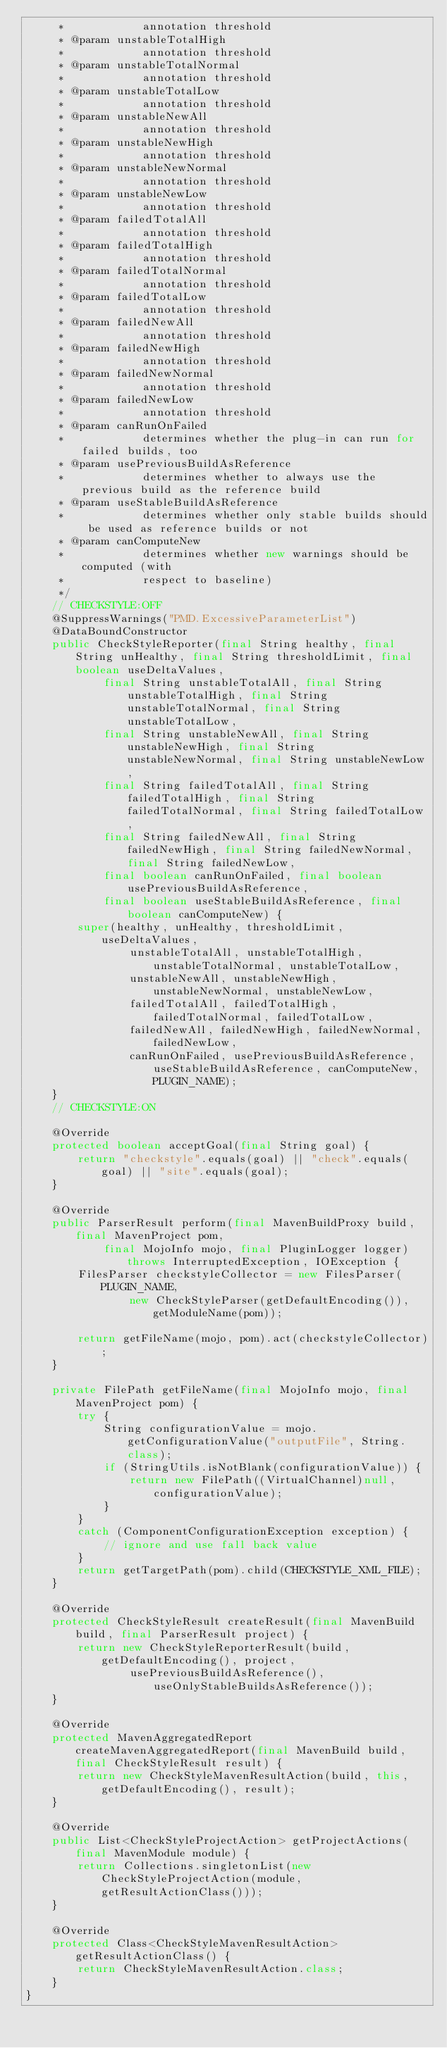Convert code to text. <code><loc_0><loc_0><loc_500><loc_500><_Java_>     *            annotation threshold
     * @param unstableTotalHigh
     *            annotation threshold
     * @param unstableTotalNormal
     *            annotation threshold
     * @param unstableTotalLow
     *            annotation threshold
     * @param unstableNewAll
     *            annotation threshold
     * @param unstableNewHigh
     *            annotation threshold
     * @param unstableNewNormal
     *            annotation threshold
     * @param unstableNewLow
     *            annotation threshold
     * @param failedTotalAll
     *            annotation threshold
     * @param failedTotalHigh
     *            annotation threshold
     * @param failedTotalNormal
     *            annotation threshold
     * @param failedTotalLow
     *            annotation threshold
     * @param failedNewAll
     *            annotation threshold
     * @param failedNewHigh
     *            annotation threshold
     * @param failedNewNormal
     *            annotation threshold
     * @param failedNewLow
     *            annotation threshold
     * @param canRunOnFailed
     *            determines whether the plug-in can run for failed builds, too
     * @param usePreviousBuildAsReference
     *            determines whether to always use the previous build as the reference build
     * @param useStableBuildAsReference
     *            determines whether only stable builds should be used as reference builds or not
     * @param canComputeNew
     *            determines whether new warnings should be computed (with
     *            respect to baseline)
     */
    // CHECKSTYLE:OFF
    @SuppressWarnings("PMD.ExcessiveParameterList")
    @DataBoundConstructor
    public CheckStyleReporter(final String healthy, final String unHealthy, final String thresholdLimit, final boolean useDeltaValues,
            final String unstableTotalAll, final String unstableTotalHigh, final String unstableTotalNormal, final String unstableTotalLow,
            final String unstableNewAll, final String unstableNewHigh, final String unstableNewNormal, final String unstableNewLow,
            final String failedTotalAll, final String failedTotalHigh, final String failedTotalNormal, final String failedTotalLow,
            final String failedNewAll, final String failedNewHigh, final String failedNewNormal, final String failedNewLow,
            final boolean canRunOnFailed, final boolean usePreviousBuildAsReference,
            final boolean useStableBuildAsReference, final boolean canComputeNew) {
        super(healthy, unHealthy, thresholdLimit, useDeltaValues,
                unstableTotalAll, unstableTotalHigh, unstableTotalNormal, unstableTotalLow,
                unstableNewAll, unstableNewHigh, unstableNewNormal, unstableNewLow,
                failedTotalAll, failedTotalHigh, failedTotalNormal, failedTotalLow,
                failedNewAll, failedNewHigh, failedNewNormal, failedNewLow,
                canRunOnFailed, usePreviousBuildAsReference, useStableBuildAsReference, canComputeNew, PLUGIN_NAME);
    }
    // CHECKSTYLE:ON

    @Override
    protected boolean acceptGoal(final String goal) {
        return "checkstyle".equals(goal) || "check".equals(goal) || "site".equals(goal);
    }

    @Override
    public ParserResult perform(final MavenBuildProxy build, final MavenProject pom,
            final MojoInfo mojo, final PluginLogger logger) throws InterruptedException, IOException {
        FilesParser checkstyleCollector = new FilesParser(PLUGIN_NAME,
                new CheckStyleParser(getDefaultEncoding()), getModuleName(pom));

        return getFileName(mojo, pom).act(checkstyleCollector);
    }

    private FilePath getFileName(final MojoInfo mojo, final MavenProject pom) {
        try {
            String configurationValue = mojo.getConfigurationValue("outputFile", String.class);
            if (StringUtils.isNotBlank(configurationValue)) {
                return new FilePath((VirtualChannel)null, configurationValue);
            }
        }
        catch (ComponentConfigurationException exception) {
            // ignore and use fall back value
        }
        return getTargetPath(pom).child(CHECKSTYLE_XML_FILE);
    }

    @Override
    protected CheckStyleResult createResult(final MavenBuild build, final ParserResult project) {
        return new CheckStyleReporterResult(build, getDefaultEncoding(), project,
                usePreviousBuildAsReference(), useOnlyStableBuildsAsReference());
    }

    @Override
    protected MavenAggregatedReport createMavenAggregatedReport(final MavenBuild build, final CheckStyleResult result) {
        return new CheckStyleMavenResultAction(build, this, getDefaultEncoding(), result);
    }

    @Override
    public List<CheckStyleProjectAction> getProjectActions(final MavenModule module) {
        return Collections.singletonList(new CheckStyleProjectAction(module, getResultActionClass()));
    }

    @Override
    protected Class<CheckStyleMavenResultAction> getResultActionClass() {
        return CheckStyleMavenResultAction.class;
    }
}

</code> 